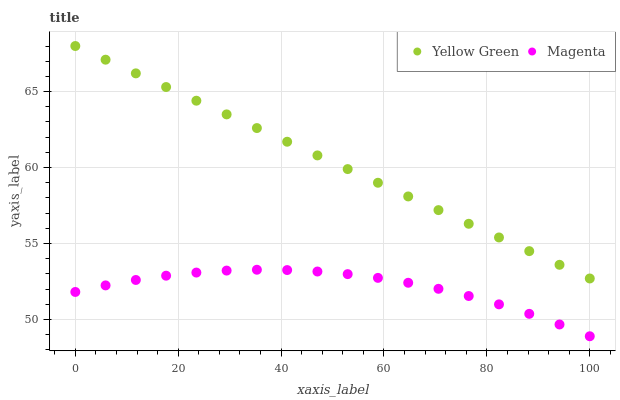Does Magenta have the minimum area under the curve?
Answer yes or no. Yes. Does Yellow Green have the maximum area under the curve?
Answer yes or no. Yes. Does Yellow Green have the minimum area under the curve?
Answer yes or no. No. Is Yellow Green the smoothest?
Answer yes or no. Yes. Is Magenta the roughest?
Answer yes or no. Yes. Is Yellow Green the roughest?
Answer yes or no. No. Does Magenta have the lowest value?
Answer yes or no. Yes. Does Yellow Green have the lowest value?
Answer yes or no. No. Does Yellow Green have the highest value?
Answer yes or no. Yes. Is Magenta less than Yellow Green?
Answer yes or no. Yes. Is Yellow Green greater than Magenta?
Answer yes or no. Yes. Does Magenta intersect Yellow Green?
Answer yes or no. No. 